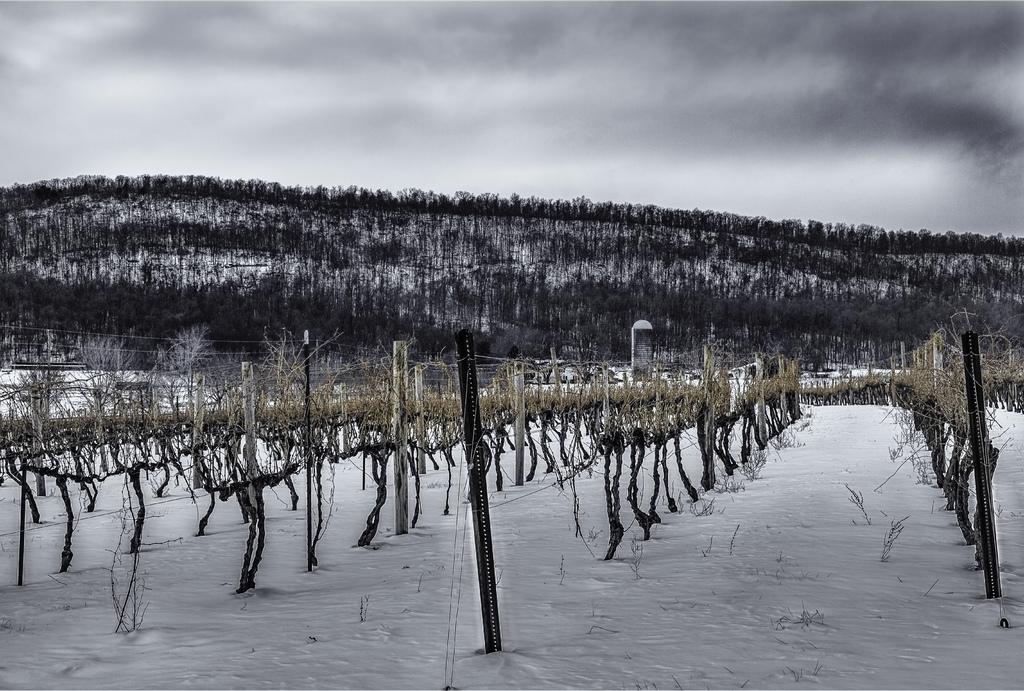How would you summarize this image in a sentence or two? In this picture we can see few metal rods, trees and pillars. 